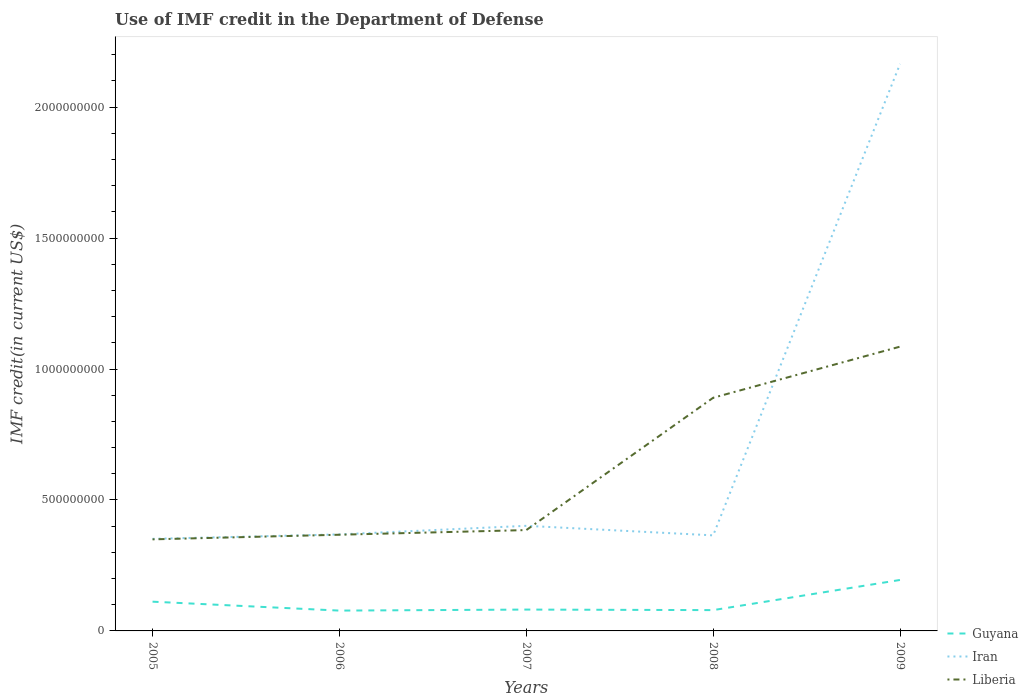How many different coloured lines are there?
Offer a very short reply. 3. Does the line corresponding to Liberia intersect with the line corresponding to Iran?
Ensure brevity in your answer.  Yes. Is the number of lines equal to the number of legend labels?
Make the answer very short. Yes. Across all years, what is the maximum IMF credit in the Department of Defense in Iran?
Your answer should be very brief. 3.52e+08. In which year was the IMF credit in the Department of Defense in Liberia maximum?
Your response must be concise. 2005. What is the total IMF credit in the Department of Defense in Liberia in the graph?
Ensure brevity in your answer.  -1.76e+07. What is the difference between the highest and the second highest IMF credit in the Department of Defense in Liberia?
Keep it short and to the point. 7.36e+08. How many lines are there?
Your answer should be very brief. 3. How many years are there in the graph?
Provide a succinct answer. 5. Does the graph contain any zero values?
Provide a short and direct response. No. Where does the legend appear in the graph?
Give a very brief answer. Bottom right. How many legend labels are there?
Your answer should be very brief. 3. How are the legend labels stacked?
Your answer should be compact. Vertical. What is the title of the graph?
Provide a succinct answer. Use of IMF credit in the Department of Defense. Does "Congo (Republic)" appear as one of the legend labels in the graph?
Provide a short and direct response. No. What is the label or title of the Y-axis?
Ensure brevity in your answer.  IMF credit(in current US$). What is the IMF credit(in current US$) of Guyana in 2005?
Provide a succinct answer. 1.12e+08. What is the IMF credit(in current US$) in Iran in 2005?
Your answer should be compact. 3.52e+08. What is the IMF credit(in current US$) in Liberia in 2005?
Give a very brief answer. 3.50e+08. What is the IMF credit(in current US$) of Guyana in 2006?
Your response must be concise. 7.76e+07. What is the IMF credit(in current US$) of Iran in 2006?
Ensure brevity in your answer.  3.69e+08. What is the IMF credit(in current US$) in Liberia in 2006?
Offer a very short reply. 3.67e+08. What is the IMF credit(in current US$) of Guyana in 2007?
Your answer should be compact. 8.15e+07. What is the IMF credit(in current US$) in Iran in 2007?
Ensure brevity in your answer.  4.01e+08. What is the IMF credit(in current US$) in Liberia in 2007?
Keep it short and to the point. 3.85e+08. What is the IMF credit(in current US$) of Guyana in 2008?
Provide a succinct answer. 7.95e+07. What is the IMF credit(in current US$) of Iran in 2008?
Offer a terse response. 3.65e+08. What is the IMF credit(in current US$) of Liberia in 2008?
Provide a succinct answer. 8.90e+08. What is the IMF credit(in current US$) in Guyana in 2009?
Provide a short and direct response. 1.95e+08. What is the IMF credit(in current US$) of Iran in 2009?
Keep it short and to the point. 2.17e+09. What is the IMF credit(in current US$) of Liberia in 2009?
Your answer should be very brief. 1.09e+09. Across all years, what is the maximum IMF credit(in current US$) of Guyana?
Your response must be concise. 1.95e+08. Across all years, what is the maximum IMF credit(in current US$) in Iran?
Your answer should be very brief. 2.17e+09. Across all years, what is the maximum IMF credit(in current US$) in Liberia?
Make the answer very short. 1.09e+09. Across all years, what is the minimum IMF credit(in current US$) in Guyana?
Give a very brief answer. 7.76e+07. Across all years, what is the minimum IMF credit(in current US$) of Iran?
Ensure brevity in your answer.  3.52e+08. Across all years, what is the minimum IMF credit(in current US$) of Liberia?
Provide a short and direct response. 3.50e+08. What is the total IMF credit(in current US$) in Guyana in the graph?
Your response must be concise. 5.45e+08. What is the total IMF credit(in current US$) of Iran in the graph?
Ensure brevity in your answer.  3.65e+09. What is the total IMF credit(in current US$) in Liberia in the graph?
Give a very brief answer. 3.08e+09. What is the difference between the IMF credit(in current US$) of Guyana in 2005 and that in 2006?
Offer a very short reply. 3.41e+07. What is the difference between the IMF credit(in current US$) in Iran in 2005 and that in 2006?
Offer a terse response. -1.69e+07. What is the difference between the IMF credit(in current US$) in Liberia in 2005 and that in 2006?
Keep it short and to the point. -1.76e+07. What is the difference between the IMF credit(in current US$) of Guyana in 2005 and that in 2007?
Offer a very short reply. 3.01e+07. What is the difference between the IMF credit(in current US$) in Iran in 2005 and that in 2007?
Ensure brevity in your answer.  -4.97e+07. What is the difference between the IMF credit(in current US$) in Liberia in 2005 and that in 2007?
Your answer should be compact. -3.54e+07. What is the difference between the IMF credit(in current US$) in Guyana in 2005 and that in 2008?
Your answer should be very brief. 3.22e+07. What is the difference between the IMF credit(in current US$) in Iran in 2005 and that in 2008?
Provide a succinct answer. -1.32e+07. What is the difference between the IMF credit(in current US$) of Liberia in 2005 and that in 2008?
Keep it short and to the point. -5.41e+08. What is the difference between the IMF credit(in current US$) in Guyana in 2005 and that in 2009?
Give a very brief answer. -8.30e+07. What is the difference between the IMF credit(in current US$) of Iran in 2005 and that in 2009?
Give a very brief answer. -1.81e+09. What is the difference between the IMF credit(in current US$) of Liberia in 2005 and that in 2009?
Offer a very short reply. -7.36e+08. What is the difference between the IMF credit(in current US$) in Guyana in 2006 and that in 2007?
Your response must be concise. -3.91e+06. What is the difference between the IMF credit(in current US$) in Iran in 2006 and that in 2007?
Give a very brief answer. -3.28e+07. What is the difference between the IMF credit(in current US$) of Liberia in 2006 and that in 2007?
Offer a very short reply. -1.78e+07. What is the difference between the IMF credit(in current US$) of Guyana in 2006 and that in 2008?
Keep it short and to the point. -1.85e+06. What is the difference between the IMF credit(in current US$) in Iran in 2006 and that in 2008?
Keep it short and to the point. 3.69e+06. What is the difference between the IMF credit(in current US$) of Liberia in 2006 and that in 2008?
Your answer should be compact. -5.23e+08. What is the difference between the IMF credit(in current US$) in Guyana in 2006 and that in 2009?
Your response must be concise. -1.17e+08. What is the difference between the IMF credit(in current US$) in Iran in 2006 and that in 2009?
Make the answer very short. -1.80e+09. What is the difference between the IMF credit(in current US$) in Liberia in 2006 and that in 2009?
Keep it short and to the point. -7.18e+08. What is the difference between the IMF credit(in current US$) in Guyana in 2007 and that in 2008?
Offer a very short reply. 2.06e+06. What is the difference between the IMF credit(in current US$) in Iran in 2007 and that in 2008?
Your answer should be compact. 3.65e+07. What is the difference between the IMF credit(in current US$) of Liberia in 2007 and that in 2008?
Ensure brevity in your answer.  -5.05e+08. What is the difference between the IMF credit(in current US$) in Guyana in 2007 and that in 2009?
Offer a terse response. -1.13e+08. What is the difference between the IMF credit(in current US$) in Iran in 2007 and that in 2009?
Your answer should be very brief. -1.76e+09. What is the difference between the IMF credit(in current US$) of Liberia in 2007 and that in 2009?
Make the answer very short. -7.00e+08. What is the difference between the IMF credit(in current US$) in Guyana in 2008 and that in 2009?
Your answer should be very brief. -1.15e+08. What is the difference between the IMF credit(in current US$) of Iran in 2008 and that in 2009?
Your answer should be very brief. -1.80e+09. What is the difference between the IMF credit(in current US$) of Liberia in 2008 and that in 2009?
Your answer should be very brief. -1.95e+08. What is the difference between the IMF credit(in current US$) of Guyana in 2005 and the IMF credit(in current US$) of Iran in 2006?
Offer a very short reply. -2.57e+08. What is the difference between the IMF credit(in current US$) of Guyana in 2005 and the IMF credit(in current US$) of Liberia in 2006?
Keep it short and to the point. -2.56e+08. What is the difference between the IMF credit(in current US$) of Iran in 2005 and the IMF credit(in current US$) of Liberia in 2006?
Provide a succinct answer. -1.56e+07. What is the difference between the IMF credit(in current US$) of Guyana in 2005 and the IMF credit(in current US$) of Iran in 2007?
Ensure brevity in your answer.  -2.90e+08. What is the difference between the IMF credit(in current US$) of Guyana in 2005 and the IMF credit(in current US$) of Liberia in 2007?
Offer a terse response. -2.73e+08. What is the difference between the IMF credit(in current US$) of Iran in 2005 and the IMF credit(in current US$) of Liberia in 2007?
Offer a very short reply. -3.34e+07. What is the difference between the IMF credit(in current US$) in Guyana in 2005 and the IMF credit(in current US$) in Iran in 2008?
Provide a short and direct response. -2.53e+08. What is the difference between the IMF credit(in current US$) of Guyana in 2005 and the IMF credit(in current US$) of Liberia in 2008?
Provide a short and direct response. -7.79e+08. What is the difference between the IMF credit(in current US$) of Iran in 2005 and the IMF credit(in current US$) of Liberia in 2008?
Make the answer very short. -5.39e+08. What is the difference between the IMF credit(in current US$) of Guyana in 2005 and the IMF credit(in current US$) of Iran in 2009?
Offer a terse response. -2.05e+09. What is the difference between the IMF credit(in current US$) in Guyana in 2005 and the IMF credit(in current US$) in Liberia in 2009?
Keep it short and to the point. -9.74e+08. What is the difference between the IMF credit(in current US$) in Iran in 2005 and the IMF credit(in current US$) in Liberia in 2009?
Offer a terse response. -7.34e+08. What is the difference between the IMF credit(in current US$) of Guyana in 2006 and the IMF credit(in current US$) of Iran in 2007?
Make the answer very short. -3.24e+08. What is the difference between the IMF credit(in current US$) of Guyana in 2006 and the IMF credit(in current US$) of Liberia in 2007?
Your answer should be very brief. -3.07e+08. What is the difference between the IMF credit(in current US$) in Iran in 2006 and the IMF credit(in current US$) in Liberia in 2007?
Provide a succinct answer. -1.65e+07. What is the difference between the IMF credit(in current US$) of Guyana in 2006 and the IMF credit(in current US$) of Iran in 2008?
Your answer should be compact. -2.87e+08. What is the difference between the IMF credit(in current US$) in Guyana in 2006 and the IMF credit(in current US$) in Liberia in 2008?
Provide a short and direct response. -8.13e+08. What is the difference between the IMF credit(in current US$) of Iran in 2006 and the IMF credit(in current US$) of Liberia in 2008?
Your response must be concise. -5.22e+08. What is the difference between the IMF credit(in current US$) in Guyana in 2006 and the IMF credit(in current US$) in Iran in 2009?
Make the answer very short. -2.09e+09. What is the difference between the IMF credit(in current US$) of Guyana in 2006 and the IMF credit(in current US$) of Liberia in 2009?
Provide a short and direct response. -1.01e+09. What is the difference between the IMF credit(in current US$) in Iran in 2006 and the IMF credit(in current US$) in Liberia in 2009?
Keep it short and to the point. -7.17e+08. What is the difference between the IMF credit(in current US$) in Guyana in 2007 and the IMF credit(in current US$) in Iran in 2008?
Offer a terse response. -2.83e+08. What is the difference between the IMF credit(in current US$) in Guyana in 2007 and the IMF credit(in current US$) in Liberia in 2008?
Offer a very short reply. -8.09e+08. What is the difference between the IMF credit(in current US$) of Iran in 2007 and the IMF credit(in current US$) of Liberia in 2008?
Your response must be concise. -4.89e+08. What is the difference between the IMF credit(in current US$) of Guyana in 2007 and the IMF credit(in current US$) of Iran in 2009?
Ensure brevity in your answer.  -2.08e+09. What is the difference between the IMF credit(in current US$) in Guyana in 2007 and the IMF credit(in current US$) in Liberia in 2009?
Ensure brevity in your answer.  -1.00e+09. What is the difference between the IMF credit(in current US$) in Iran in 2007 and the IMF credit(in current US$) in Liberia in 2009?
Provide a short and direct response. -6.84e+08. What is the difference between the IMF credit(in current US$) in Guyana in 2008 and the IMF credit(in current US$) in Iran in 2009?
Your response must be concise. -2.09e+09. What is the difference between the IMF credit(in current US$) in Guyana in 2008 and the IMF credit(in current US$) in Liberia in 2009?
Your answer should be very brief. -1.01e+09. What is the difference between the IMF credit(in current US$) of Iran in 2008 and the IMF credit(in current US$) of Liberia in 2009?
Provide a succinct answer. -7.21e+08. What is the average IMF credit(in current US$) of Guyana per year?
Provide a short and direct response. 1.09e+08. What is the average IMF credit(in current US$) of Iran per year?
Provide a short and direct response. 7.30e+08. What is the average IMF credit(in current US$) of Liberia per year?
Provide a short and direct response. 6.16e+08. In the year 2005, what is the difference between the IMF credit(in current US$) in Guyana and IMF credit(in current US$) in Iran?
Offer a terse response. -2.40e+08. In the year 2005, what is the difference between the IMF credit(in current US$) of Guyana and IMF credit(in current US$) of Liberia?
Provide a succinct answer. -2.38e+08. In the year 2005, what is the difference between the IMF credit(in current US$) of Iran and IMF credit(in current US$) of Liberia?
Offer a terse response. 2.00e+06. In the year 2006, what is the difference between the IMF credit(in current US$) of Guyana and IMF credit(in current US$) of Iran?
Provide a succinct answer. -2.91e+08. In the year 2006, what is the difference between the IMF credit(in current US$) in Guyana and IMF credit(in current US$) in Liberia?
Your response must be concise. -2.90e+08. In the year 2006, what is the difference between the IMF credit(in current US$) in Iran and IMF credit(in current US$) in Liberia?
Keep it short and to the point. 1.28e+06. In the year 2007, what is the difference between the IMF credit(in current US$) of Guyana and IMF credit(in current US$) of Iran?
Offer a very short reply. -3.20e+08. In the year 2007, what is the difference between the IMF credit(in current US$) of Guyana and IMF credit(in current US$) of Liberia?
Your answer should be compact. -3.04e+08. In the year 2007, what is the difference between the IMF credit(in current US$) of Iran and IMF credit(in current US$) of Liberia?
Offer a terse response. 1.63e+07. In the year 2008, what is the difference between the IMF credit(in current US$) in Guyana and IMF credit(in current US$) in Iran?
Your response must be concise. -2.85e+08. In the year 2008, what is the difference between the IMF credit(in current US$) of Guyana and IMF credit(in current US$) of Liberia?
Ensure brevity in your answer.  -8.11e+08. In the year 2008, what is the difference between the IMF credit(in current US$) of Iran and IMF credit(in current US$) of Liberia?
Your answer should be very brief. -5.25e+08. In the year 2009, what is the difference between the IMF credit(in current US$) of Guyana and IMF credit(in current US$) of Iran?
Make the answer very short. -1.97e+09. In the year 2009, what is the difference between the IMF credit(in current US$) in Guyana and IMF credit(in current US$) in Liberia?
Offer a very short reply. -8.91e+08. In the year 2009, what is the difference between the IMF credit(in current US$) of Iran and IMF credit(in current US$) of Liberia?
Your answer should be very brief. 1.08e+09. What is the ratio of the IMF credit(in current US$) in Guyana in 2005 to that in 2006?
Offer a terse response. 1.44. What is the ratio of the IMF credit(in current US$) in Iran in 2005 to that in 2006?
Your answer should be very brief. 0.95. What is the ratio of the IMF credit(in current US$) of Liberia in 2005 to that in 2006?
Provide a succinct answer. 0.95. What is the ratio of the IMF credit(in current US$) in Guyana in 2005 to that in 2007?
Your response must be concise. 1.37. What is the ratio of the IMF credit(in current US$) in Iran in 2005 to that in 2007?
Your answer should be compact. 0.88. What is the ratio of the IMF credit(in current US$) in Liberia in 2005 to that in 2007?
Keep it short and to the point. 0.91. What is the ratio of the IMF credit(in current US$) in Guyana in 2005 to that in 2008?
Provide a succinct answer. 1.41. What is the ratio of the IMF credit(in current US$) of Iran in 2005 to that in 2008?
Make the answer very short. 0.96. What is the ratio of the IMF credit(in current US$) in Liberia in 2005 to that in 2008?
Provide a short and direct response. 0.39. What is the ratio of the IMF credit(in current US$) of Guyana in 2005 to that in 2009?
Ensure brevity in your answer.  0.57. What is the ratio of the IMF credit(in current US$) of Iran in 2005 to that in 2009?
Ensure brevity in your answer.  0.16. What is the ratio of the IMF credit(in current US$) in Liberia in 2005 to that in 2009?
Ensure brevity in your answer.  0.32. What is the ratio of the IMF credit(in current US$) of Guyana in 2006 to that in 2007?
Give a very brief answer. 0.95. What is the ratio of the IMF credit(in current US$) of Iran in 2006 to that in 2007?
Make the answer very short. 0.92. What is the ratio of the IMF credit(in current US$) of Liberia in 2006 to that in 2007?
Ensure brevity in your answer.  0.95. What is the ratio of the IMF credit(in current US$) in Guyana in 2006 to that in 2008?
Ensure brevity in your answer.  0.98. What is the ratio of the IMF credit(in current US$) of Iran in 2006 to that in 2008?
Ensure brevity in your answer.  1.01. What is the ratio of the IMF credit(in current US$) of Liberia in 2006 to that in 2008?
Offer a very short reply. 0.41. What is the ratio of the IMF credit(in current US$) in Guyana in 2006 to that in 2009?
Keep it short and to the point. 0.4. What is the ratio of the IMF credit(in current US$) in Iran in 2006 to that in 2009?
Offer a very short reply. 0.17. What is the ratio of the IMF credit(in current US$) in Liberia in 2006 to that in 2009?
Offer a very short reply. 0.34. What is the ratio of the IMF credit(in current US$) in Guyana in 2007 to that in 2008?
Offer a terse response. 1.03. What is the ratio of the IMF credit(in current US$) of Iran in 2007 to that in 2008?
Provide a short and direct response. 1.1. What is the ratio of the IMF credit(in current US$) in Liberia in 2007 to that in 2008?
Ensure brevity in your answer.  0.43. What is the ratio of the IMF credit(in current US$) of Guyana in 2007 to that in 2009?
Offer a terse response. 0.42. What is the ratio of the IMF credit(in current US$) of Iran in 2007 to that in 2009?
Offer a terse response. 0.19. What is the ratio of the IMF credit(in current US$) of Liberia in 2007 to that in 2009?
Make the answer very short. 0.35. What is the ratio of the IMF credit(in current US$) in Guyana in 2008 to that in 2009?
Ensure brevity in your answer.  0.41. What is the ratio of the IMF credit(in current US$) of Iran in 2008 to that in 2009?
Provide a succinct answer. 0.17. What is the ratio of the IMF credit(in current US$) of Liberia in 2008 to that in 2009?
Your answer should be compact. 0.82. What is the difference between the highest and the second highest IMF credit(in current US$) in Guyana?
Offer a terse response. 8.30e+07. What is the difference between the highest and the second highest IMF credit(in current US$) of Iran?
Your answer should be compact. 1.76e+09. What is the difference between the highest and the second highest IMF credit(in current US$) in Liberia?
Provide a short and direct response. 1.95e+08. What is the difference between the highest and the lowest IMF credit(in current US$) of Guyana?
Make the answer very short. 1.17e+08. What is the difference between the highest and the lowest IMF credit(in current US$) of Iran?
Make the answer very short. 1.81e+09. What is the difference between the highest and the lowest IMF credit(in current US$) in Liberia?
Your answer should be compact. 7.36e+08. 